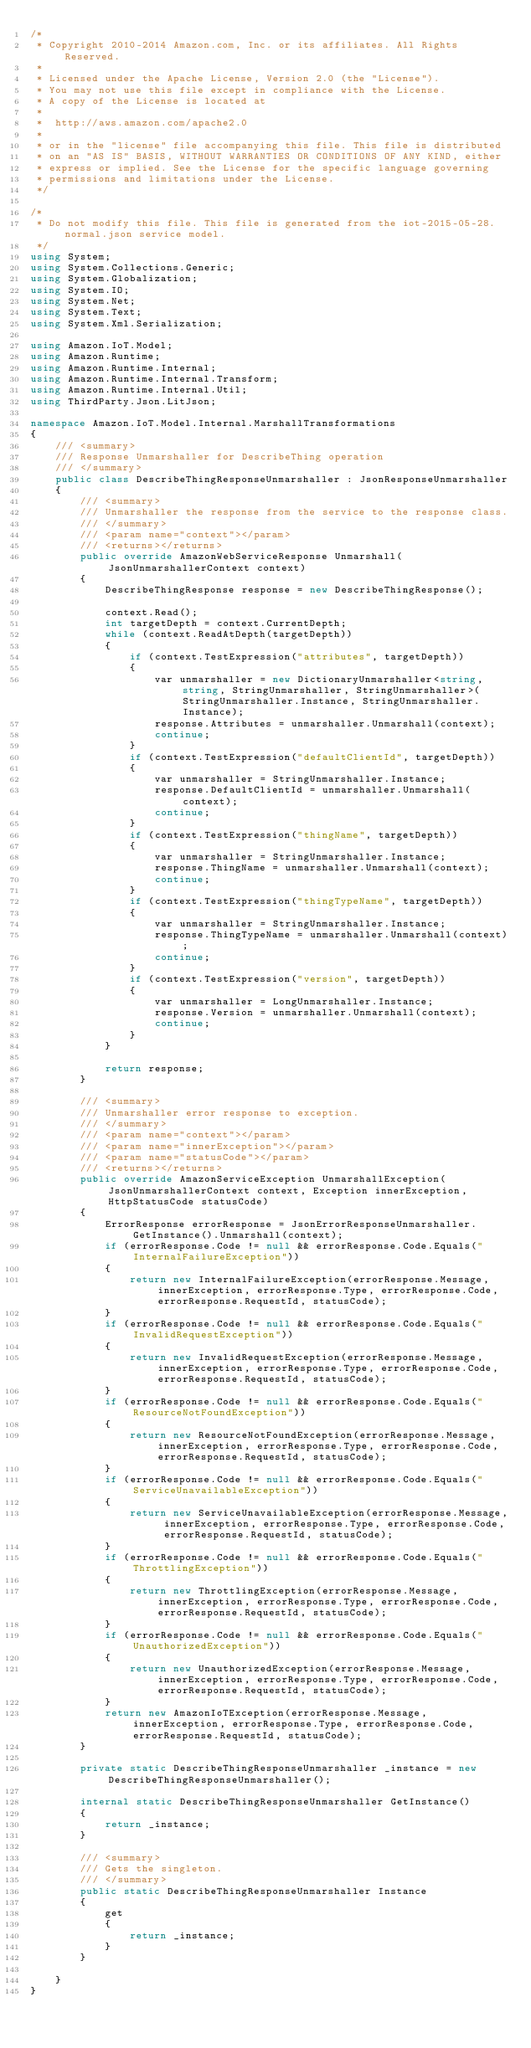<code> <loc_0><loc_0><loc_500><loc_500><_C#_>/*
 * Copyright 2010-2014 Amazon.com, Inc. or its affiliates. All Rights Reserved.
 * 
 * Licensed under the Apache License, Version 2.0 (the "License").
 * You may not use this file except in compliance with the License.
 * A copy of the License is located at
 * 
 *  http://aws.amazon.com/apache2.0
 * 
 * or in the "license" file accompanying this file. This file is distributed
 * on an "AS IS" BASIS, WITHOUT WARRANTIES OR CONDITIONS OF ANY KIND, either
 * express or implied. See the License for the specific language governing
 * permissions and limitations under the License.
 */

/*
 * Do not modify this file. This file is generated from the iot-2015-05-28.normal.json service model.
 */
using System;
using System.Collections.Generic;
using System.Globalization;
using System.IO;
using System.Net;
using System.Text;
using System.Xml.Serialization;

using Amazon.IoT.Model;
using Amazon.Runtime;
using Amazon.Runtime.Internal;
using Amazon.Runtime.Internal.Transform;
using Amazon.Runtime.Internal.Util;
using ThirdParty.Json.LitJson;

namespace Amazon.IoT.Model.Internal.MarshallTransformations
{
    /// <summary>
    /// Response Unmarshaller for DescribeThing operation
    /// </summary>  
    public class DescribeThingResponseUnmarshaller : JsonResponseUnmarshaller
    {
        /// <summary>
        /// Unmarshaller the response from the service to the response class.
        /// </summary>  
        /// <param name="context"></param>
        /// <returns></returns>
        public override AmazonWebServiceResponse Unmarshall(JsonUnmarshallerContext context)
        {
            DescribeThingResponse response = new DescribeThingResponse();

            context.Read();
            int targetDepth = context.CurrentDepth;
            while (context.ReadAtDepth(targetDepth))
            {
                if (context.TestExpression("attributes", targetDepth))
                {
                    var unmarshaller = new DictionaryUnmarshaller<string, string, StringUnmarshaller, StringUnmarshaller>(StringUnmarshaller.Instance, StringUnmarshaller.Instance);
                    response.Attributes = unmarshaller.Unmarshall(context);
                    continue;
                }
                if (context.TestExpression("defaultClientId", targetDepth))
                {
                    var unmarshaller = StringUnmarshaller.Instance;
                    response.DefaultClientId = unmarshaller.Unmarshall(context);
                    continue;
                }
                if (context.TestExpression("thingName", targetDepth))
                {
                    var unmarshaller = StringUnmarshaller.Instance;
                    response.ThingName = unmarshaller.Unmarshall(context);
                    continue;
                }
                if (context.TestExpression("thingTypeName", targetDepth))
                {
                    var unmarshaller = StringUnmarshaller.Instance;
                    response.ThingTypeName = unmarshaller.Unmarshall(context);
                    continue;
                }
                if (context.TestExpression("version", targetDepth))
                {
                    var unmarshaller = LongUnmarshaller.Instance;
                    response.Version = unmarshaller.Unmarshall(context);
                    continue;
                }
            }

            return response;
        }

        /// <summary>
        /// Unmarshaller error response to exception.
        /// </summary>  
        /// <param name="context"></param>
        /// <param name="innerException"></param>
        /// <param name="statusCode"></param>
        /// <returns></returns>
        public override AmazonServiceException UnmarshallException(JsonUnmarshallerContext context, Exception innerException, HttpStatusCode statusCode)
        {
            ErrorResponse errorResponse = JsonErrorResponseUnmarshaller.GetInstance().Unmarshall(context);
            if (errorResponse.Code != null && errorResponse.Code.Equals("InternalFailureException"))
            {
                return new InternalFailureException(errorResponse.Message, innerException, errorResponse.Type, errorResponse.Code, errorResponse.RequestId, statusCode);
            }
            if (errorResponse.Code != null && errorResponse.Code.Equals("InvalidRequestException"))
            {
                return new InvalidRequestException(errorResponse.Message, innerException, errorResponse.Type, errorResponse.Code, errorResponse.RequestId, statusCode);
            }
            if (errorResponse.Code != null && errorResponse.Code.Equals("ResourceNotFoundException"))
            {
                return new ResourceNotFoundException(errorResponse.Message, innerException, errorResponse.Type, errorResponse.Code, errorResponse.RequestId, statusCode);
            }
            if (errorResponse.Code != null && errorResponse.Code.Equals("ServiceUnavailableException"))
            {
                return new ServiceUnavailableException(errorResponse.Message, innerException, errorResponse.Type, errorResponse.Code, errorResponse.RequestId, statusCode);
            }
            if (errorResponse.Code != null && errorResponse.Code.Equals("ThrottlingException"))
            {
                return new ThrottlingException(errorResponse.Message, innerException, errorResponse.Type, errorResponse.Code, errorResponse.RequestId, statusCode);
            }
            if (errorResponse.Code != null && errorResponse.Code.Equals("UnauthorizedException"))
            {
                return new UnauthorizedException(errorResponse.Message, innerException, errorResponse.Type, errorResponse.Code, errorResponse.RequestId, statusCode);
            }
            return new AmazonIoTException(errorResponse.Message, innerException, errorResponse.Type, errorResponse.Code, errorResponse.RequestId, statusCode);
        }

        private static DescribeThingResponseUnmarshaller _instance = new DescribeThingResponseUnmarshaller();        

        internal static DescribeThingResponseUnmarshaller GetInstance()
        {
            return _instance;
        }

        /// <summary>
        /// Gets the singleton.
        /// </summary>  
        public static DescribeThingResponseUnmarshaller Instance
        {
            get
            {
                return _instance;
            }
        }

    }
}</code> 